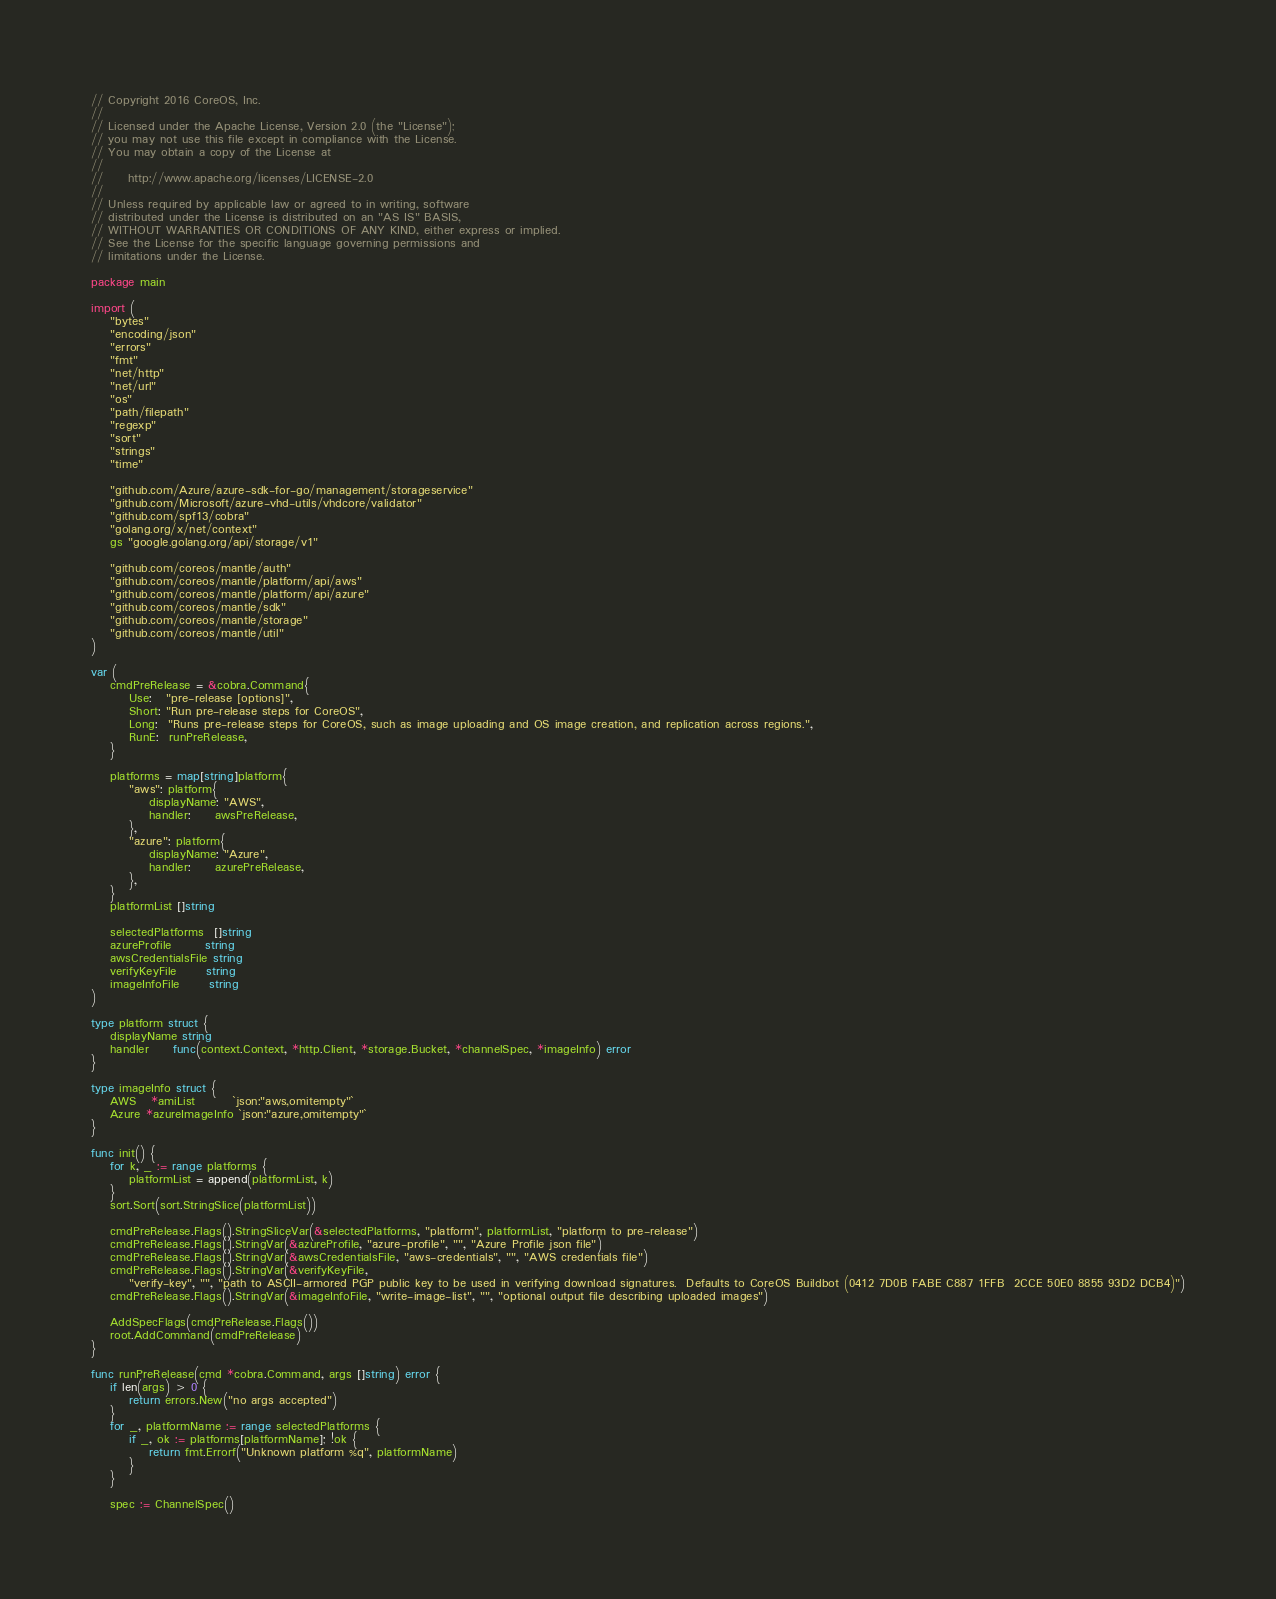<code> <loc_0><loc_0><loc_500><loc_500><_Go_>// Copyright 2016 CoreOS, Inc.
//
// Licensed under the Apache License, Version 2.0 (the "License");
// you may not use this file except in compliance with the License.
// You may obtain a copy of the License at
//
//     http://www.apache.org/licenses/LICENSE-2.0
//
// Unless required by applicable law or agreed to in writing, software
// distributed under the License is distributed on an "AS IS" BASIS,
// WITHOUT WARRANTIES OR CONDITIONS OF ANY KIND, either express or implied.
// See the License for the specific language governing permissions and
// limitations under the License.

package main

import (
	"bytes"
	"encoding/json"
	"errors"
	"fmt"
	"net/http"
	"net/url"
	"os"
	"path/filepath"
	"regexp"
	"sort"
	"strings"
	"time"

	"github.com/Azure/azure-sdk-for-go/management/storageservice"
	"github.com/Microsoft/azure-vhd-utils/vhdcore/validator"
	"github.com/spf13/cobra"
	"golang.org/x/net/context"
	gs "google.golang.org/api/storage/v1"

	"github.com/coreos/mantle/auth"
	"github.com/coreos/mantle/platform/api/aws"
	"github.com/coreos/mantle/platform/api/azure"
	"github.com/coreos/mantle/sdk"
	"github.com/coreos/mantle/storage"
	"github.com/coreos/mantle/util"
)

var (
	cmdPreRelease = &cobra.Command{
		Use:   "pre-release [options]",
		Short: "Run pre-release steps for CoreOS",
		Long:  "Runs pre-release steps for CoreOS, such as image uploading and OS image creation, and replication across regions.",
		RunE:  runPreRelease,
	}

	platforms = map[string]platform{
		"aws": platform{
			displayName: "AWS",
			handler:     awsPreRelease,
		},
		"azure": platform{
			displayName: "Azure",
			handler:     azurePreRelease,
		},
	}
	platformList []string

	selectedPlatforms  []string
	azureProfile       string
	awsCredentialsFile string
	verifyKeyFile      string
	imageInfoFile      string
)

type platform struct {
	displayName string
	handler     func(context.Context, *http.Client, *storage.Bucket, *channelSpec, *imageInfo) error
}

type imageInfo struct {
	AWS   *amiList        `json:"aws,omitempty"`
	Azure *azureImageInfo `json:"azure,omitempty"`
}

func init() {
	for k, _ := range platforms {
		platformList = append(platformList, k)
	}
	sort.Sort(sort.StringSlice(platformList))

	cmdPreRelease.Flags().StringSliceVar(&selectedPlatforms, "platform", platformList, "platform to pre-release")
	cmdPreRelease.Flags().StringVar(&azureProfile, "azure-profile", "", "Azure Profile json file")
	cmdPreRelease.Flags().StringVar(&awsCredentialsFile, "aws-credentials", "", "AWS credentials file")
	cmdPreRelease.Flags().StringVar(&verifyKeyFile,
		"verify-key", "", "path to ASCII-armored PGP public key to be used in verifying download signatures.  Defaults to CoreOS Buildbot (0412 7D0B FABE C887 1FFB  2CCE 50E0 8855 93D2 DCB4)")
	cmdPreRelease.Flags().StringVar(&imageInfoFile, "write-image-list", "", "optional output file describing uploaded images")

	AddSpecFlags(cmdPreRelease.Flags())
	root.AddCommand(cmdPreRelease)
}

func runPreRelease(cmd *cobra.Command, args []string) error {
	if len(args) > 0 {
		return errors.New("no args accepted")
	}
	for _, platformName := range selectedPlatforms {
		if _, ok := platforms[platformName]; !ok {
			return fmt.Errorf("Unknown platform %q", platformName)
		}
	}

	spec := ChannelSpec()</code> 